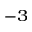<formula> <loc_0><loc_0><loc_500><loc_500>^ { - 3 }</formula> 